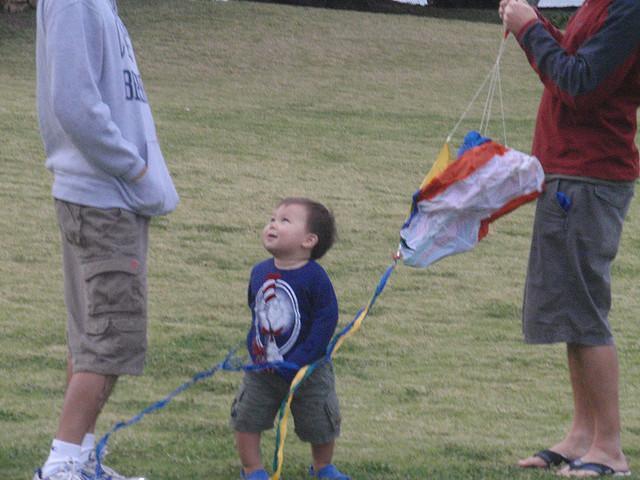How many adults are present?
Give a very brief answer. 2. How many people can be seen?
Give a very brief answer. 3. 